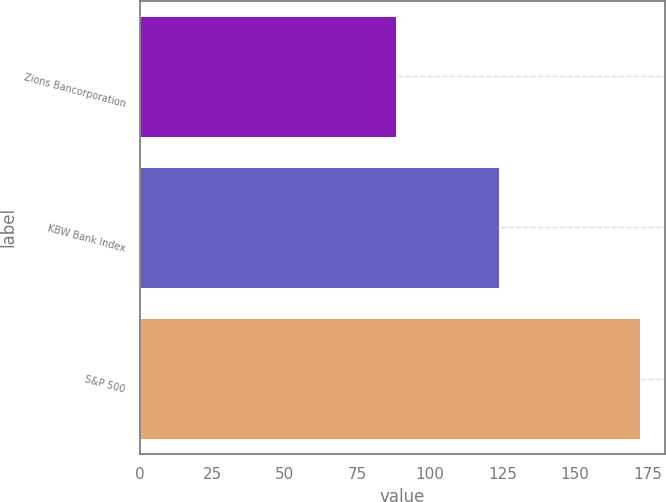Convert chart. <chart><loc_0><loc_0><loc_500><loc_500><bar_chart><fcel>Zions Bancorporation<fcel>KBW Bank Index<fcel>S&P 500<nl><fcel>88.4<fcel>123.8<fcel>172.3<nl></chart> 